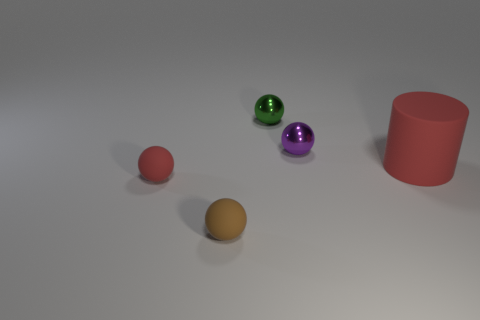Are there any small green objects made of the same material as the red sphere?
Provide a short and direct response. No. The ball that is the same color as the large rubber thing is what size?
Provide a short and direct response. Small. The matte thing behind the red thing that is left of the large red thing is what color?
Your answer should be very brief. Red. Does the green thing have the same size as the red matte ball?
Your answer should be compact. Yes. What number of cylinders are either tiny red matte objects or green objects?
Offer a very short reply. 0. What number of metal spheres are in front of the small purple sphere on the right side of the tiny red ball?
Your response must be concise. 0. Is the green thing the same shape as the tiny red object?
Your answer should be very brief. Yes. What is the shape of the red thing that is left of the red thing on the right side of the brown matte sphere?
Offer a very short reply. Sphere. How big is the purple ball?
Make the answer very short. Small. There is a tiny brown object; what shape is it?
Your answer should be very brief. Sphere. 